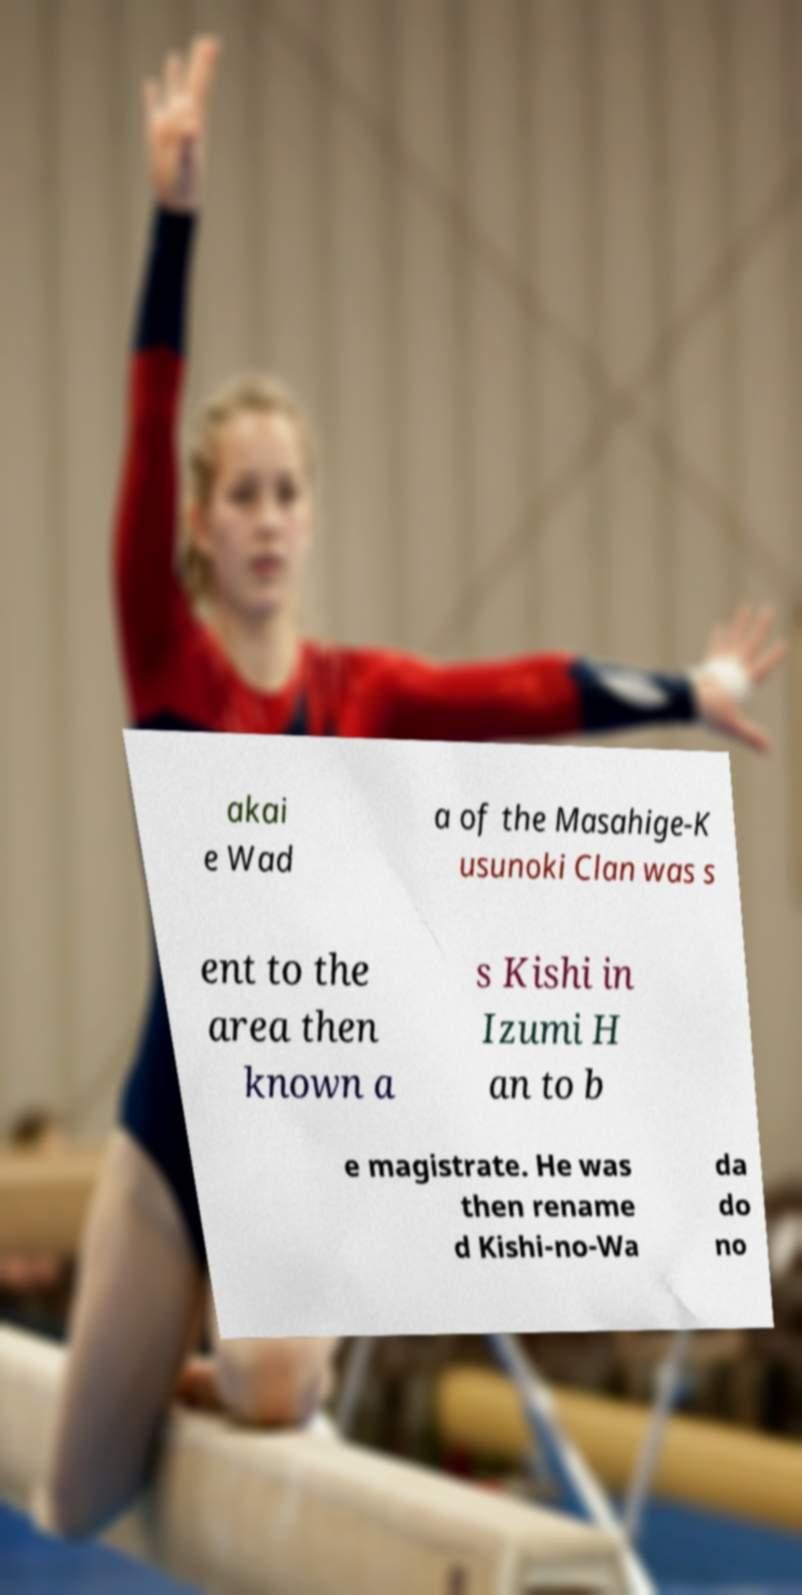Can you accurately transcribe the text from the provided image for me? akai e Wad a of the Masahige-K usunoki Clan was s ent to the area then known a s Kishi in Izumi H an to b e magistrate. He was then rename d Kishi-no-Wa da do no 